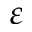Convert formula to latex. <formula><loc_0><loc_0><loc_500><loc_500>\varepsilon</formula> 